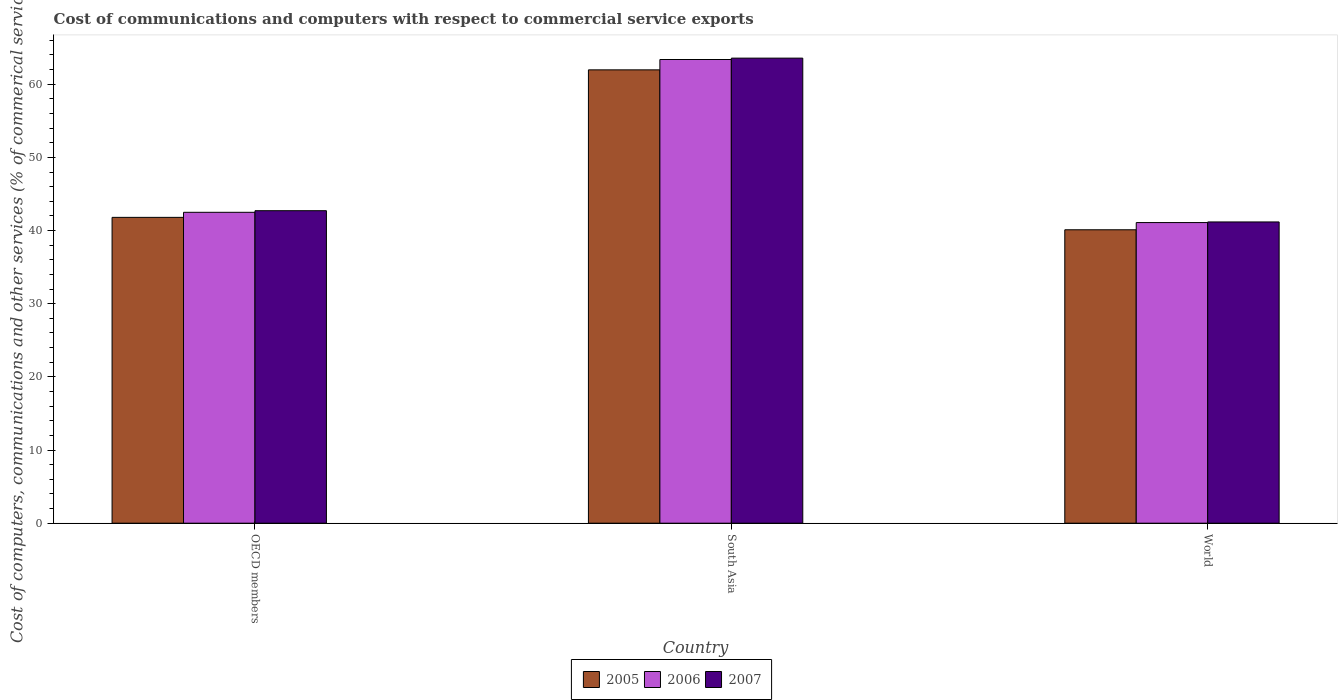How many different coloured bars are there?
Make the answer very short. 3. Are the number of bars per tick equal to the number of legend labels?
Provide a succinct answer. Yes. How many bars are there on the 2nd tick from the left?
Your answer should be very brief. 3. How many bars are there on the 3rd tick from the right?
Your answer should be very brief. 3. What is the label of the 1st group of bars from the left?
Your answer should be very brief. OECD members. In how many cases, is the number of bars for a given country not equal to the number of legend labels?
Make the answer very short. 0. What is the cost of communications and computers in 2006 in World?
Ensure brevity in your answer.  41.09. Across all countries, what is the maximum cost of communications and computers in 2007?
Make the answer very short. 63.57. Across all countries, what is the minimum cost of communications and computers in 2005?
Give a very brief answer. 40.11. In which country was the cost of communications and computers in 2005 maximum?
Offer a very short reply. South Asia. In which country was the cost of communications and computers in 2007 minimum?
Your answer should be very brief. World. What is the total cost of communications and computers in 2006 in the graph?
Ensure brevity in your answer.  146.97. What is the difference between the cost of communications and computers in 2006 in OECD members and that in World?
Ensure brevity in your answer.  1.4. What is the difference between the cost of communications and computers in 2005 in World and the cost of communications and computers in 2007 in OECD members?
Offer a terse response. -2.61. What is the average cost of communications and computers in 2006 per country?
Ensure brevity in your answer.  48.99. What is the difference between the cost of communications and computers of/in 2005 and cost of communications and computers of/in 2006 in World?
Provide a short and direct response. -0.98. What is the ratio of the cost of communications and computers in 2007 in South Asia to that in World?
Ensure brevity in your answer.  1.54. What is the difference between the highest and the second highest cost of communications and computers in 2005?
Provide a succinct answer. -1.7. What is the difference between the highest and the lowest cost of communications and computers in 2005?
Offer a terse response. 21.86. In how many countries, is the cost of communications and computers in 2006 greater than the average cost of communications and computers in 2006 taken over all countries?
Make the answer very short. 1. What does the 2nd bar from the left in OECD members represents?
Your answer should be compact. 2006. What does the 2nd bar from the right in South Asia represents?
Provide a succinct answer. 2006. Is it the case that in every country, the sum of the cost of communications and computers in 2006 and cost of communications and computers in 2005 is greater than the cost of communications and computers in 2007?
Give a very brief answer. Yes. How many countries are there in the graph?
Your answer should be very brief. 3. What is the difference between two consecutive major ticks on the Y-axis?
Provide a short and direct response. 10. Are the values on the major ticks of Y-axis written in scientific E-notation?
Your response must be concise. No. How are the legend labels stacked?
Your response must be concise. Horizontal. What is the title of the graph?
Ensure brevity in your answer.  Cost of communications and computers with respect to commercial service exports. What is the label or title of the Y-axis?
Give a very brief answer. Cost of computers, communications and other services (% of commerical service exports). What is the Cost of computers, communications and other services (% of commerical service exports) in 2005 in OECD members?
Provide a succinct answer. 41.8. What is the Cost of computers, communications and other services (% of commerical service exports) of 2006 in OECD members?
Your response must be concise. 42.5. What is the Cost of computers, communications and other services (% of commerical service exports) of 2007 in OECD members?
Offer a terse response. 42.72. What is the Cost of computers, communications and other services (% of commerical service exports) of 2005 in South Asia?
Offer a very short reply. 61.97. What is the Cost of computers, communications and other services (% of commerical service exports) of 2006 in South Asia?
Provide a short and direct response. 63.38. What is the Cost of computers, communications and other services (% of commerical service exports) of 2007 in South Asia?
Ensure brevity in your answer.  63.57. What is the Cost of computers, communications and other services (% of commerical service exports) of 2005 in World?
Offer a terse response. 40.11. What is the Cost of computers, communications and other services (% of commerical service exports) of 2006 in World?
Offer a very short reply. 41.09. What is the Cost of computers, communications and other services (% of commerical service exports) in 2007 in World?
Give a very brief answer. 41.18. Across all countries, what is the maximum Cost of computers, communications and other services (% of commerical service exports) in 2005?
Your answer should be very brief. 61.97. Across all countries, what is the maximum Cost of computers, communications and other services (% of commerical service exports) of 2006?
Offer a very short reply. 63.38. Across all countries, what is the maximum Cost of computers, communications and other services (% of commerical service exports) of 2007?
Provide a short and direct response. 63.57. Across all countries, what is the minimum Cost of computers, communications and other services (% of commerical service exports) of 2005?
Keep it short and to the point. 40.11. Across all countries, what is the minimum Cost of computers, communications and other services (% of commerical service exports) of 2006?
Provide a succinct answer. 41.09. Across all countries, what is the minimum Cost of computers, communications and other services (% of commerical service exports) in 2007?
Your answer should be very brief. 41.18. What is the total Cost of computers, communications and other services (% of commerical service exports) in 2005 in the graph?
Provide a succinct answer. 143.88. What is the total Cost of computers, communications and other services (% of commerical service exports) in 2006 in the graph?
Offer a very short reply. 146.97. What is the total Cost of computers, communications and other services (% of commerical service exports) of 2007 in the graph?
Offer a very short reply. 147.46. What is the difference between the Cost of computers, communications and other services (% of commerical service exports) of 2005 in OECD members and that in South Asia?
Provide a short and direct response. -20.16. What is the difference between the Cost of computers, communications and other services (% of commerical service exports) of 2006 in OECD members and that in South Asia?
Your answer should be compact. -20.88. What is the difference between the Cost of computers, communications and other services (% of commerical service exports) of 2007 in OECD members and that in South Asia?
Your answer should be compact. -20.85. What is the difference between the Cost of computers, communications and other services (% of commerical service exports) of 2005 in OECD members and that in World?
Offer a terse response. 1.7. What is the difference between the Cost of computers, communications and other services (% of commerical service exports) in 2006 in OECD members and that in World?
Ensure brevity in your answer.  1.4. What is the difference between the Cost of computers, communications and other services (% of commerical service exports) in 2007 in OECD members and that in World?
Ensure brevity in your answer.  1.54. What is the difference between the Cost of computers, communications and other services (% of commerical service exports) of 2005 in South Asia and that in World?
Your response must be concise. 21.86. What is the difference between the Cost of computers, communications and other services (% of commerical service exports) in 2006 in South Asia and that in World?
Offer a terse response. 22.29. What is the difference between the Cost of computers, communications and other services (% of commerical service exports) in 2007 in South Asia and that in World?
Provide a succinct answer. 22.39. What is the difference between the Cost of computers, communications and other services (% of commerical service exports) in 2005 in OECD members and the Cost of computers, communications and other services (% of commerical service exports) in 2006 in South Asia?
Ensure brevity in your answer.  -21.58. What is the difference between the Cost of computers, communications and other services (% of commerical service exports) in 2005 in OECD members and the Cost of computers, communications and other services (% of commerical service exports) in 2007 in South Asia?
Offer a terse response. -21.77. What is the difference between the Cost of computers, communications and other services (% of commerical service exports) in 2006 in OECD members and the Cost of computers, communications and other services (% of commerical service exports) in 2007 in South Asia?
Provide a succinct answer. -21.07. What is the difference between the Cost of computers, communications and other services (% of commerical service exports) of 2005 in OECD members and the Cost of computers, communications and other services (% of commerical service exports) of 2006 in World?
Offer a terse response. 0.71. What is the difference between the Cost of computers, communications and other services (% of commerical service exports) in 2005 in OECD members and the Cost of computers, communications and other services (% of commerical service exports) in 2007 in World?
Your answer should be compact. 0.62. What is the difference between the Cost of computers, communications and other services (% of commerical service exports) of 2006 in OECD members and the Cost of computers, communications and other services (% of commerical service exports) of 2007 in World?
Provide a short and direct response. 1.32. What is the difference between the Cost of computers, communications and other services (% of commerical service exports) in 2005 in South Asia and the Cost of computers, communications and other services (% of commerical service exports) in 2006 in World?
Give a very brief answer. 20.88. What is the difference between the Cost of computers, communications and other services (% of commerical service exports) of 2005 in South Asia and the Cost of computers, communications and other services (% of commerical service exports) of 2007 in World?
Make the answer very short. 20.79. What is the difference between the Cost of computers, communications and other services (% of commerical service exports) in 2006 in South Asia and the Cost of computers, communications and other services (% of commerical service exports) in 2007 in World?
Give a very brief answer. 22.2. What is the average Cost of computers, communications and other services (% of commerical service exports) of 2005 per country?
Ensure brevity in your answer.  47.96. What is the average Cost of computers, communications and other services (% of commerical service exports) in 2006 per country?
Give a very brief answer. 48.99. What is the average Cost of computers, communications and other services (% of commerical service exports) in 2007 per country?
Ensure brevity in your answer.  49.15. What is the difference between the Cost of computers, communications and other services (% of commerical service exports) of 2005 and Cost of computers, communications and other services (% of commerical service exports) of 2006 in OECD members?
Provide a short and direct response. -0.69. What is the difference between the Cost of computers, communications and other services (% of commerical service exports) in 2005 and Cost of computers, communications and other services (% of commerical service exports) in 2007 in OECD members?
Offer a terse response. -0.91. What is the difference between the Cost of computers, communications and other services (% of commerical service exports) in 2006 and Cost of computers, communications and other services (% of commerical service exports) in 2007 in OECD members?
Keep it short and to the point. -0.22. What is the difference between the Cost of computers, communications and other services (% of commerical service exports) in 2005 and Cost of computers, communications and other services (% of commerical service exports) in 2006 in South Asia?
Keep it short and to the point. -1.41. What is the difference between the Cost of computers, communications and other services (% of commerical service exports) of 2005 and Cost of computers, communications and other services (% of commerical service exports) of 2007 in South Asia?
Your answer should be compact. -1.6. What is the difference between the Cost of computers, communications and other services (% of commerical service exports) in 2006 and Cost of computers, communications and other services (% of commerical service exports) in 2007 in South Asia?
Ensure brevity in your answer.  -0.19. What is the difference between the Cost of computers, communications and other services (% of commerical service exports) in 2005 and Cost of computers, communications and other services (% of commerical service exports) in 2006 in World?
Your response must be concise. -0.98. What is the difference between the Cost of computers, communications and other services (% of commerical service exports) in 2005 and Cost of computers, communications and other services (% of commerical service exports) in 2007 in World?
Provide a short and direct response. -1.07. What is the difference between the Cost of computers, communications and other services (% of commerical service exports) of 2006 and Cost of computers, communications and other services (% of commerical service exports) of 2007 in World?
Offer a very short reply. -0.09. What is the ratio of the Cost of computers, communications and other services (% of commerical service exports) of 2005 in OECD members to that in South Asia?
Keep it short and to the point. 0.67. What is the ratio of the Cost of computers, communications and other services (% of commerical service exports) in 2006 in OECD members to that in South Asia?
Your answer should be compact. 0.67. What is the ratio of the Cost of computers, communications and other services (% of commerical service exports) in 2007 in OECD members to that in South Asia?
Provide a short and direct response. 0.67. What is the ratio of the Cost of computers, communications and other services (% of commerical service exports) of 2005 in OECD members to that in World?
Give a very brief answer. 1.04. What is the ratio of the Cost of computers, communications and other services (% of commerical service exports) in 2006 in OECD members to that in World?
Provide a short and direct response. 1.03. What is the ratio of the Cost of computers, communications and other services (% of commerical service exports) of 2007 in OECD members to that in World?
Provide a succinct answer. 1.04. What is the ratio of the Cost of computers, communications and other services (% of commerical service exports) in 2005 in South Asia to that in World?
Your response must be concise. 1.54. What is the ratio of the Cost of computers, communications and other services (% of commerical service exports) in 2006 in South Asia to that in World?
Make the answer very short. 1.54. What is the ratio of the Cost of computers, communications and other services (% of commerical service exports) of 2007 in South Asia to that in World?
Your answer should be very brief. 1.54. What is the difference between the highest and the second highest Cost of computers, communications and other services (% of commerical service exports) in 2005?
Your answer should be compact. 20.16. What is the difference between the highest and the second highest Cost of computers, communications and other services (% of commerical service exports) of 2006?
Your answer should be compact. 20.88. What is the difference between the highest and the second highest Cost of computers, communications and other services (% of commerical service exports) of 2007?
Your answer should be compact. 20.85. What is the difference between the highest and the lowest Cost of computers, communications and other services (% of commerical service exports) in 2005?
Provide a short and direct response. 21.86. What is the difference between the highest and the lowest Cost of computers, communications and other services (% of commerical service exports) of 2006?
Make the answer very short. 22.29. What is the difference between the highest and the lowest Cost of computers, communications and other services (% of commerical service exports) in 2007?
Keep it short and to the point. 22.39. 